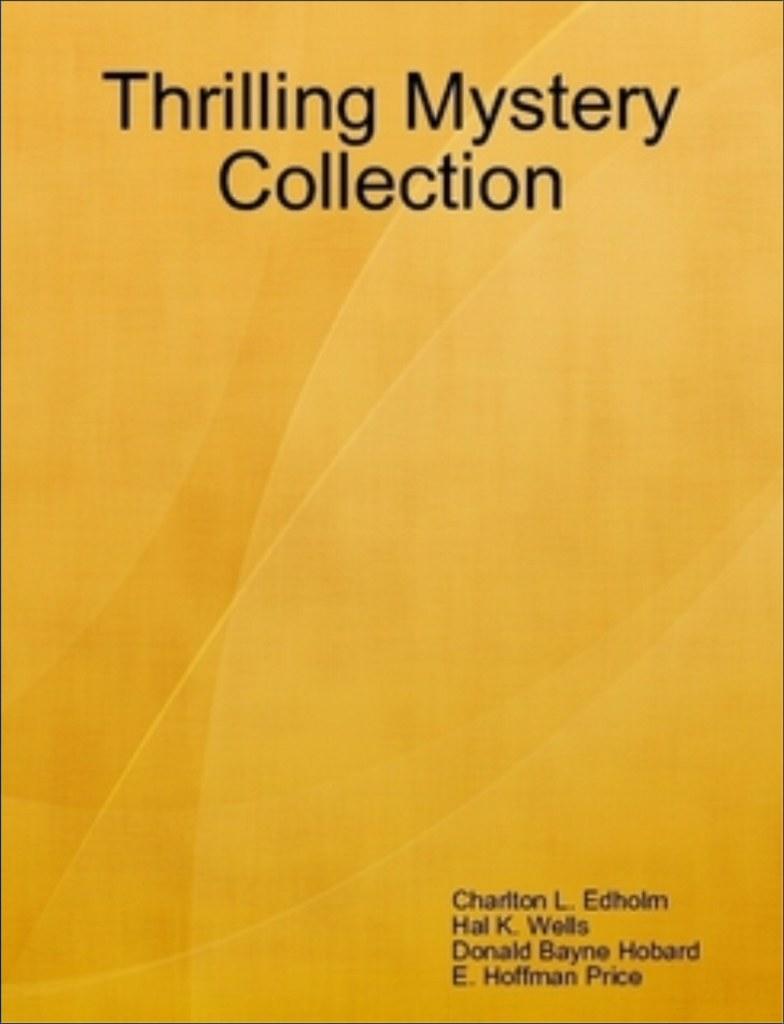Is this a college textbook?
Offer a very short reply. Unanswerable. What book is this?
Your response must be concise. Thrilling mystery collection. 